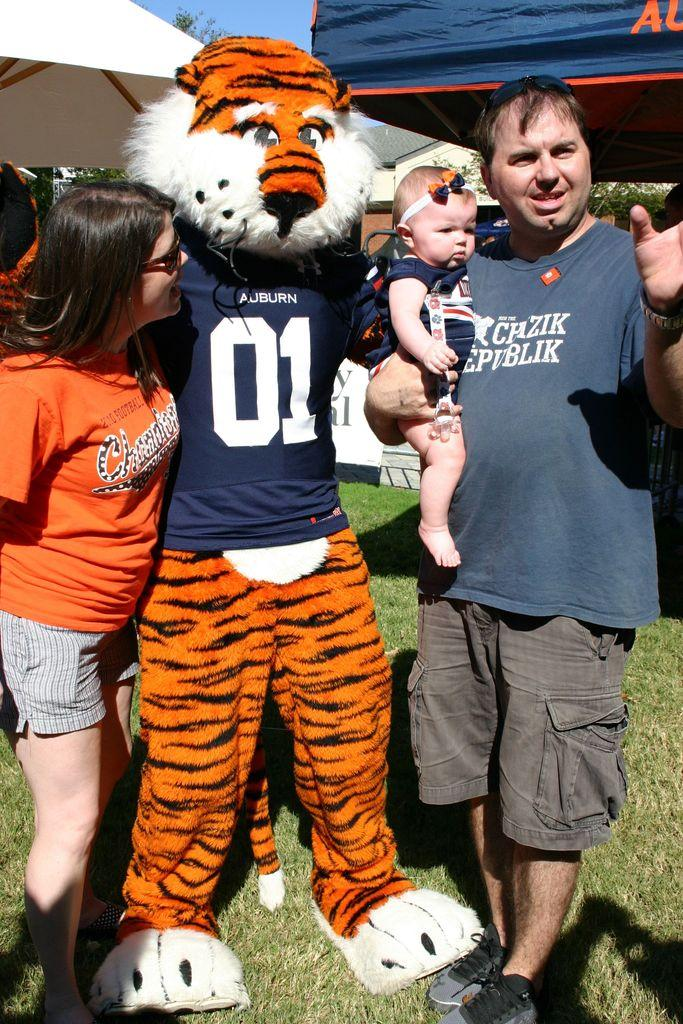How many people are in the image? There is a group of people in the image, but the exact number cannot be determined from the provided facts. What can be seen in the background of the image? There are tents, trees, and the sky visible in the background of the image. What type of finger can be seen pointing at the tents in the image? There is no finger visible in the image, let alone pointing at the tents. 